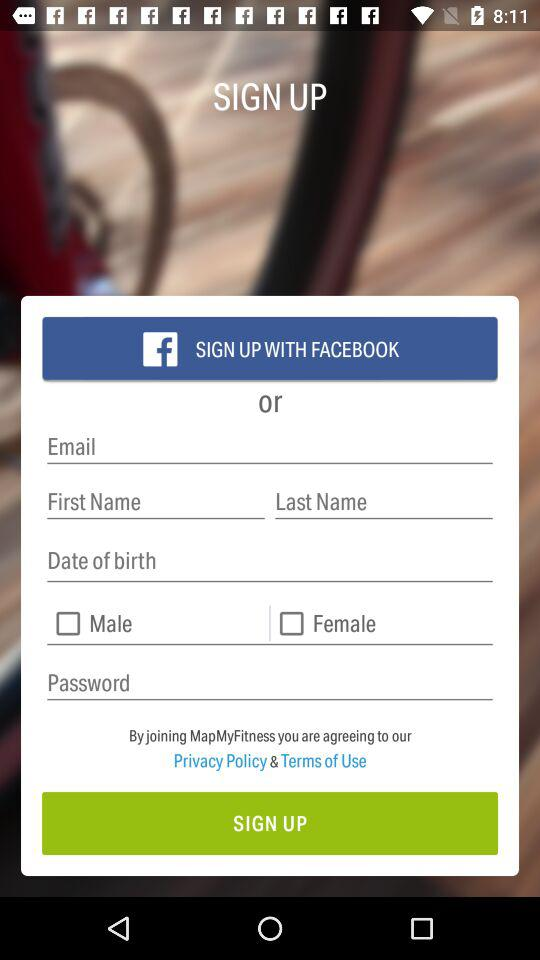Through what application can a user sign in? A user can sign in through "FACEBOOK". 